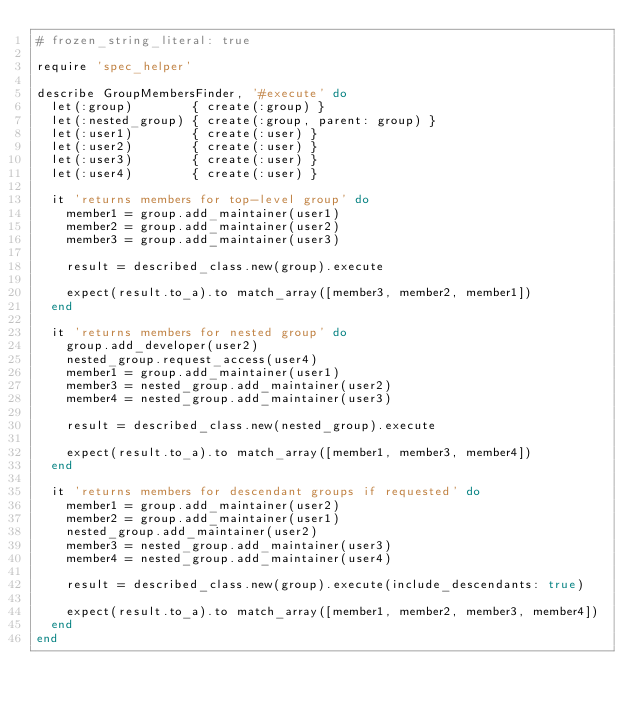<code> <loc_0><loc_0><loc_500><loc_500><_Ruby_># frozen_string_literal: true

require 'spec_helper'

describe GroupMembersFinder, '#execute' do
  let(:group)        { create(:group) }
  let(:nested_group) { create(:group, parent: group) }
  let(:user1)        { create(:user) }
  let(:user2)        { create(:user) }
  let(:user3)        { create(:user) }
  let(:user4)        { create(:user) }

  it 'returns members for top-level group' do
    member1 = group.add_maintainer(user1)
    member2 = group.add_maintainer(user2)
    member3 = group.add_maintainer(user3)

    result = described_class.new(group).execute

    expect(result.to_a).to match_array([member3, member2, member1])
  end

  it 'returns members for nested group' do
    group.add_developer(user2)
    nested_group.request_access(user4)
    member1 = group.add_maintainer(user1)
    member3 = nested_group.add_maintainer(user2)
    member4 = nested_group.add_maintainer(user3)

    result = described_class.new(nested_group).execute

    expect(result.to_a).to match_array([member1, member3, member4])
  end

  it 'returns members for descendant groups if requested' do
    member1 = group.add_maintainer(user2)
    member2 = group.add_maintainer(user1)
    nested_group.add_maintainer(user2)
    member3 = nested_group.add_maintainer(user3)
    member4 = nested_group.add_maintainer(user4)

    result = described_class.new(group).execute(include_descendants: true)

    expect(result.to_a).to match_array([member1, member2, member3, member4])
  end
end
</code> 